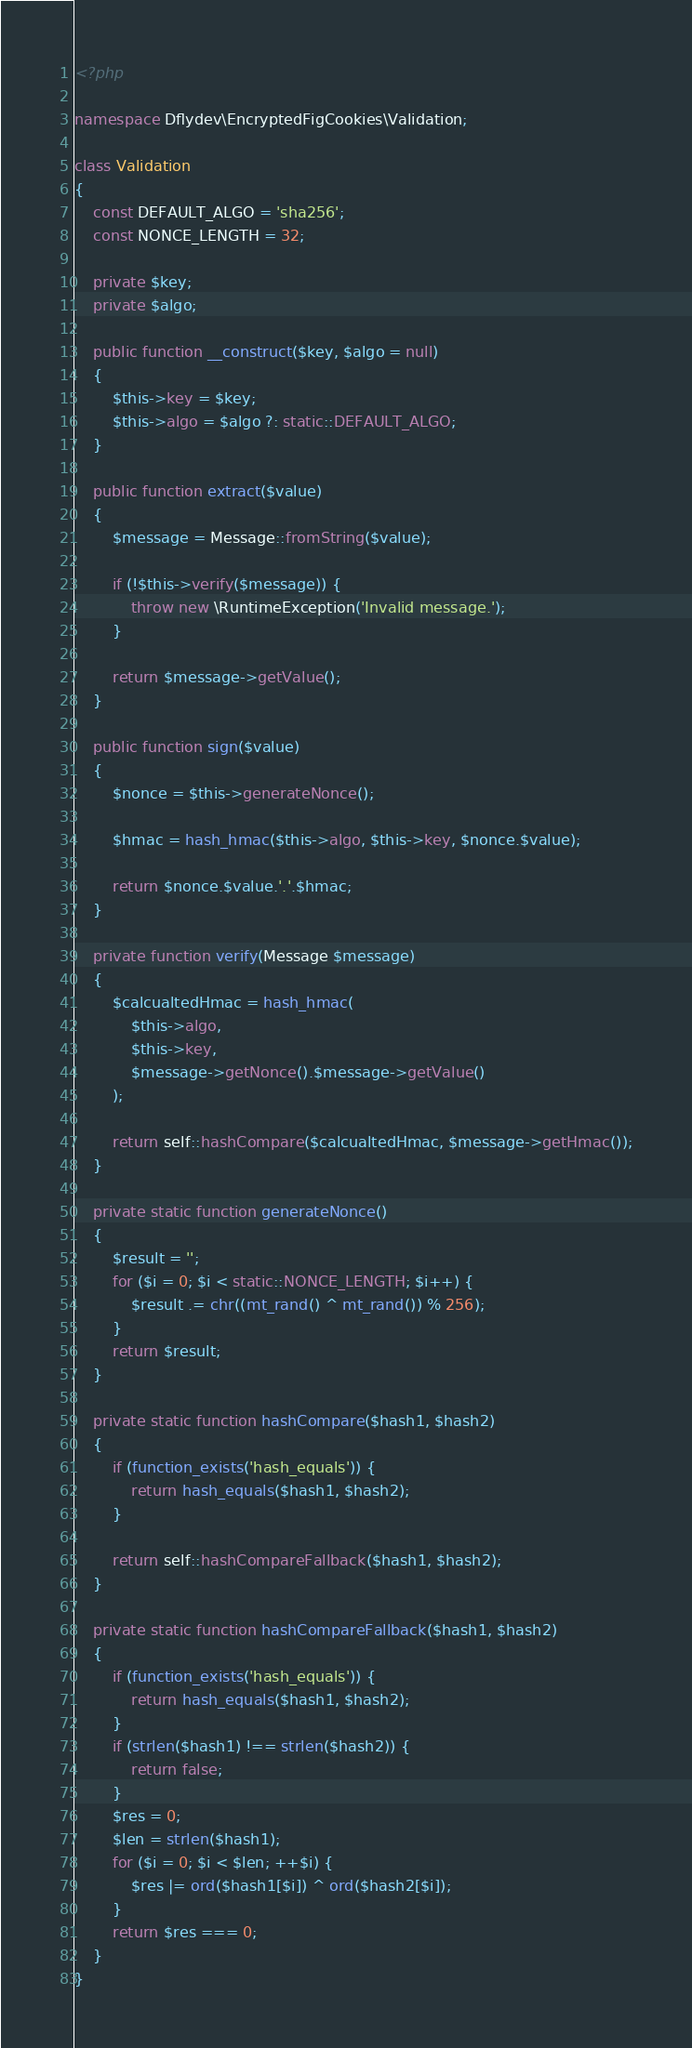<code> <loc_0><loc_0><loc_500><loc_500><_PHP_><?php

namespace Dflydev\EncryptedFigCookies\Validation;

class Validation
{
    const DEFAULT_ALGO = 'sha256';
    const NONCE_LENGTH = 32;

    private $key;
    private $algo;

    public function __construct($key, $algo = null)
    {
        $this->key = $key;
        $this->algo = $algo ?: static::DEFAULT_ALGO;
    }

    public function extract($value)
    {
        $message = Message::fromString($value);

        if (!$this->verify($message)) {
            throw new \RuntimeException('Invalid message.');
        }

        return $message->getValue();
    }

    public function sign($value)
    {
        $nonce = $this->generateNonce();

        $hmac = hash_hmac($this->algo, $this->key, $nonce.$value);

        return $nonce.$value.'.'.$hmac;
    }

    private function verify(Message $message)
    {
        $calcualtedHmac = hash_hmac(
            $this->algo,
            $this->key,
            $message->getNonce().$message->getValue()
        );

        return self::hashCompare($calcualtedHmac, $message->getHmac());
    }

    private static function generateNonce()
    {
        $result = '';
        for ($i = 0; $i < static::NONCE_LENGTH; $i++) {
            $result .= chr((mt_rand() ^ mt_rand()) % 256);
        }
        return $result;
    }

    private static function hashCompare($hash1, $hash2)
    {
        if (function_exists('hash_equals')) {
            return hash_equals($hash1, $hash2);
        }

        return self::hashCompareFallback($hash1, $hash2);
    }

    private static function hashCompareFallback($hash1, $hash2)
    {
        if (function_exists('hash_equals')) {
            return hash_equals($hash1, $hash2);
        }
        if (strlen($hash1) !== strlen($hash2)) {
            return false;
        }
        $res = 0;
        $len = strlen($hash1);
        for ($i = 0; $i < $len; ++$i) {
            $res |= ord($hash1[$i]) ^ ord($hash2[$i]);
        }
        return $res === 0;
    }
}
</code> 